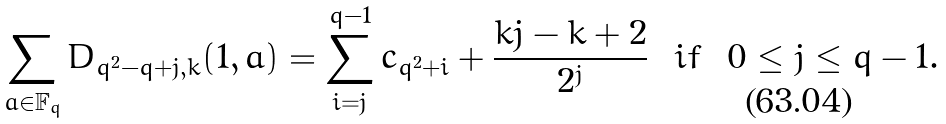Convert formula to latex. <formula><loc_0><loc_0><loc_500><loc_500>& \sum _ { a \in { \mathbb { F } _ { q } } } D _ { q ^ { 2 } - q + j , k } ( 1 , a ) = \sum _ { i = j } ^ { q - 1 } c _ { q ^ { 2 } + i } + \frac { k j - k + 2 } { 2 ^ { j } } \ \ i f \ \ 0 \leq j \leq q - 1 .</formula> 